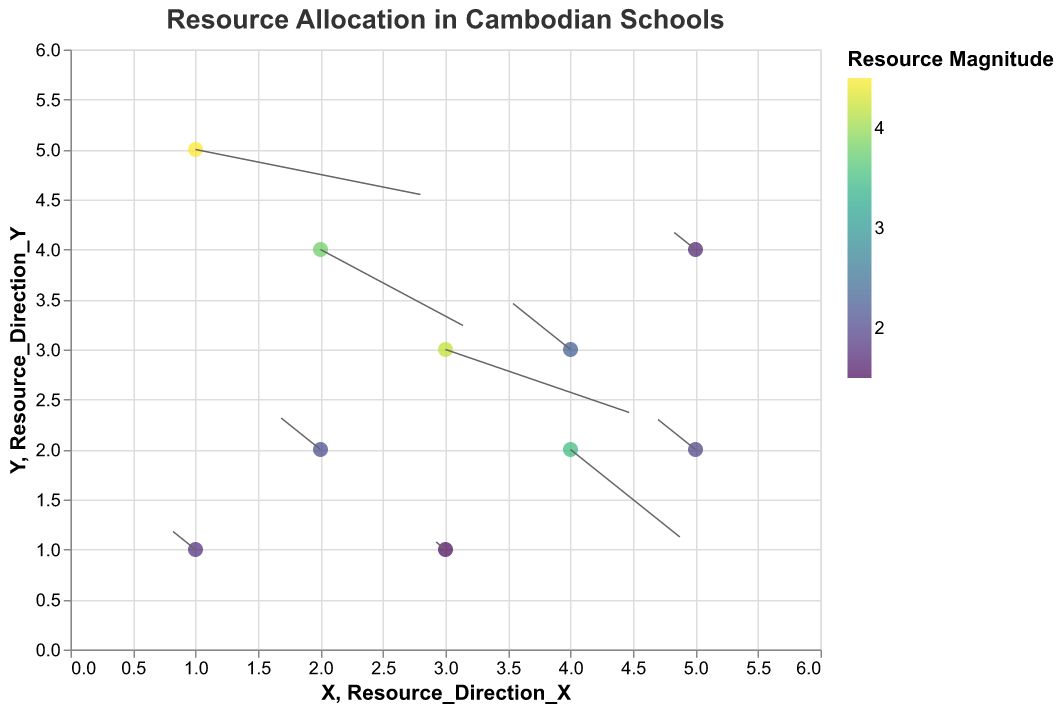Which school has the highest resource magnitude? According to the plot, Northbridge International School Cambodia has the largest resource magnitude from the color scale.
Answer: Northbridge International School Cambodia Which school has the smallest resource magnitude? Based on the color scale, Chea Sim Santhor Mok High School has the smallest resource magnitude.
Answer: Chea Sim Santhor Mok High School Are international schools generally allocated more resources than local schools in Phnom Penh? By comparing the colors representing resource magnitudes, international schools (with higher resource values and lighter shades) generally have more resources than local schools (with lower resource values and darker shades).
Answer: Yes What is the general trend in resource allocation direction between international schools and local schools? International schools tend to have vectors (arrows) pointing downwards and to the right, indicating high magnitudes and resource direction towards those quadrants. Local schools generally have arrows pointing upwards and to the left, indicating lower magnitudes.
Answer: International schools: down-right; Local schools: up-left How does the resource magnitude of Zaman International School compare to that of Preah Sisowath High School? Zaman International School has a resource magnitude of 3.8, while Preah Sisowath High School has a magnitude of 2.1. 3.8 is considerably higher than 2.1.
Answer: Zaman International School has higher resources Which school is located at (4, 2) on the plot, and what is its resource magnitude? The school at (4, 2) is CIA First International School. According to the color scale, its resource magnitude is 3.5.
Answer: CIA First International School, 3.5 What is the range of resource magnitudes across all schools? The smallest resource magnitude is 1.5 (Chea Sim Santhor Mok High School), and the largest is 4.5 (Northbridge International School Cambodia). Hence, the range is 4.5 - 1.5 = 3.0.
Answer: 3.0 Comparing the resource direction vectors, which school has the steepest downward allocation? Northbridge International School Cambodia's vector (0.8, -0.2) is the steepest downward compared to other vectors, indicating a downward allocation trend.
Answer: Northbridge International School Cambodia Is there a correlation between the position (X, Y) of the schools and their resource allocation magnitudes? Schools with higher X and Y values (international schools) generally show higher resource magnitudes, while schools with lower X and Y values (local schools) show lower magnitudes, indicating a positive correlation.
Answer: Yes, positive correlation 